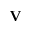Convert formula to latex. <formula><loc_0><loc_0><loc_500><loc_500>{ \mathbf V }</formula> 